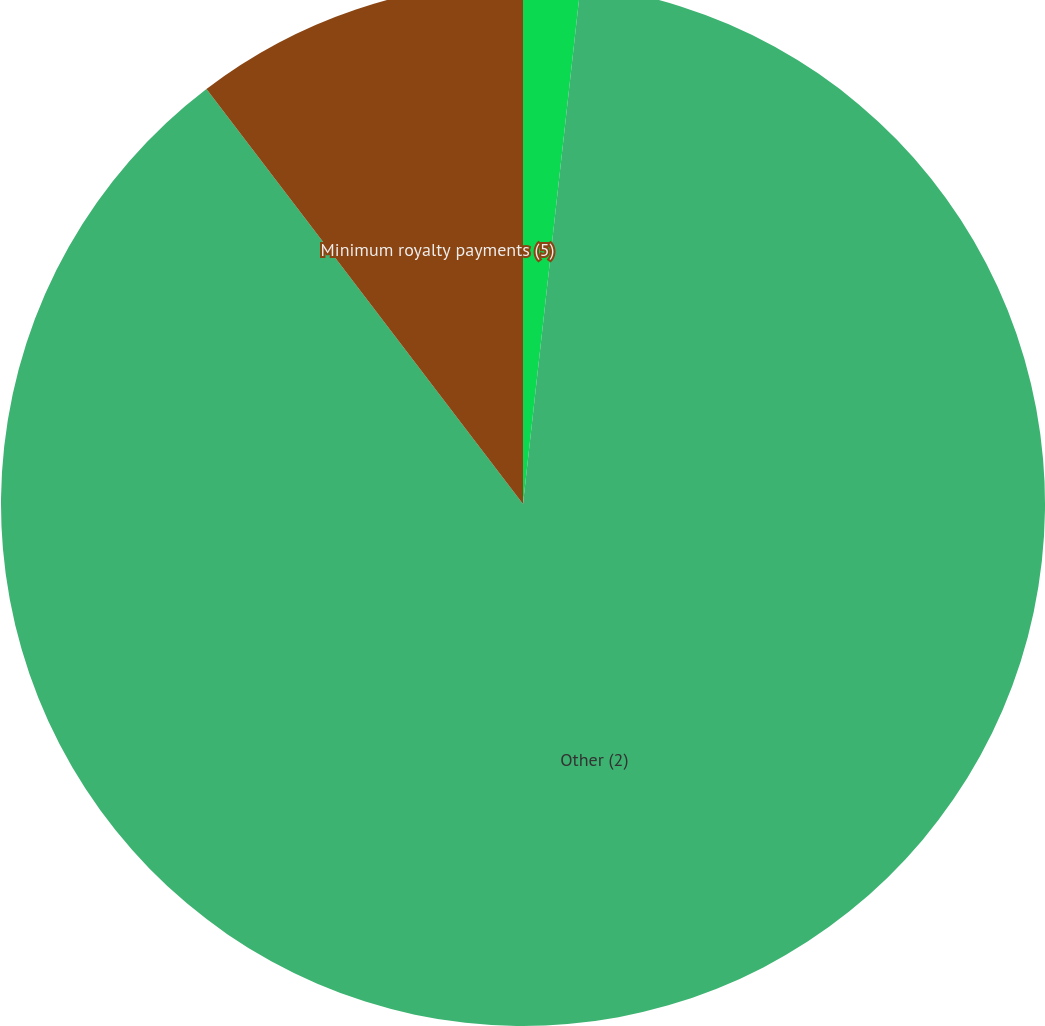Convert chart. <chart><loc_0><loc_0><loc_500><loc_500><pie_chart><fcel>Long-term debt (1)<fcel>Other (2)<fcel>Minimum royalty payments (5)<nl><fcel>1.76%<fcel>87.87%<fcel>10.37%<nl></chart> 